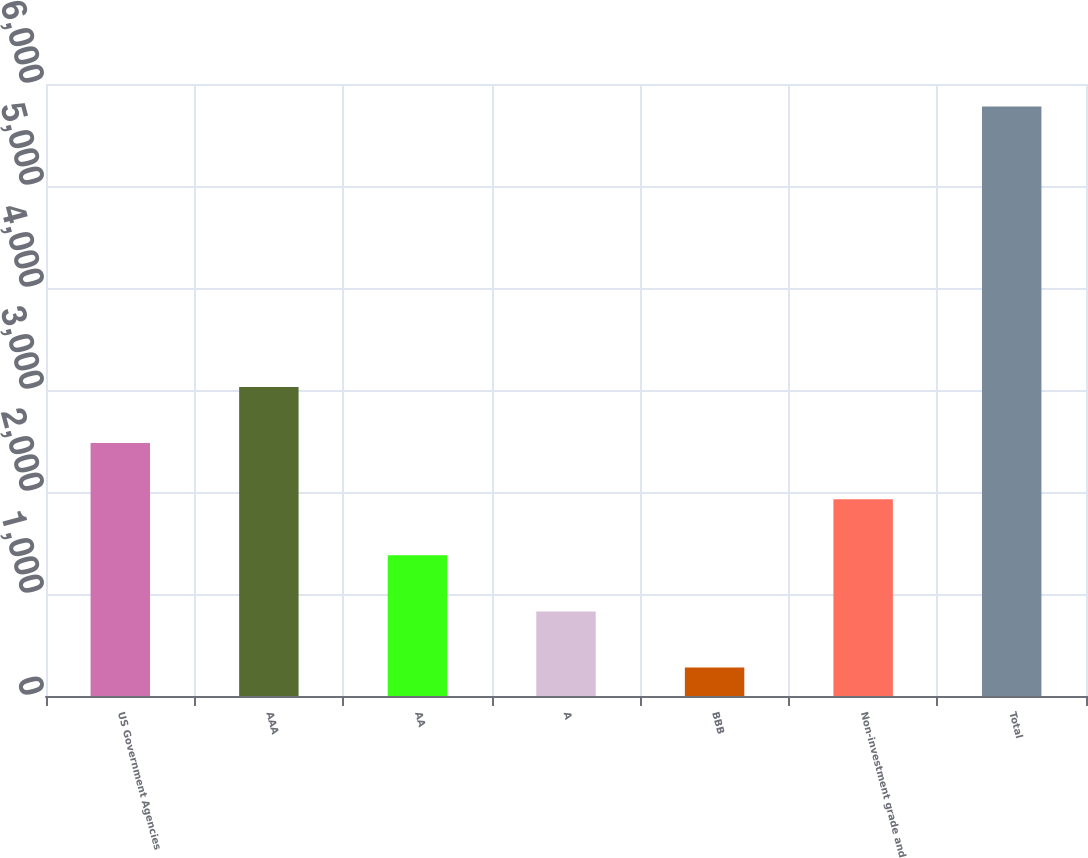Convert chart. <chart><loc_0><loc_0><loc_500><loc_500><bar_chart><fcel>US Government Agencies<fcel>AAA<fcel>AA<fcel>A<fcel>BBB<fcel>Non-investment grade and<fcel>Total<nl><fcel>2479.4<fcel>3029.5<fcel>1379.2<fcel>829.1<fcel>279<fcel>1929.3<fcel>5780<nl></chart> 